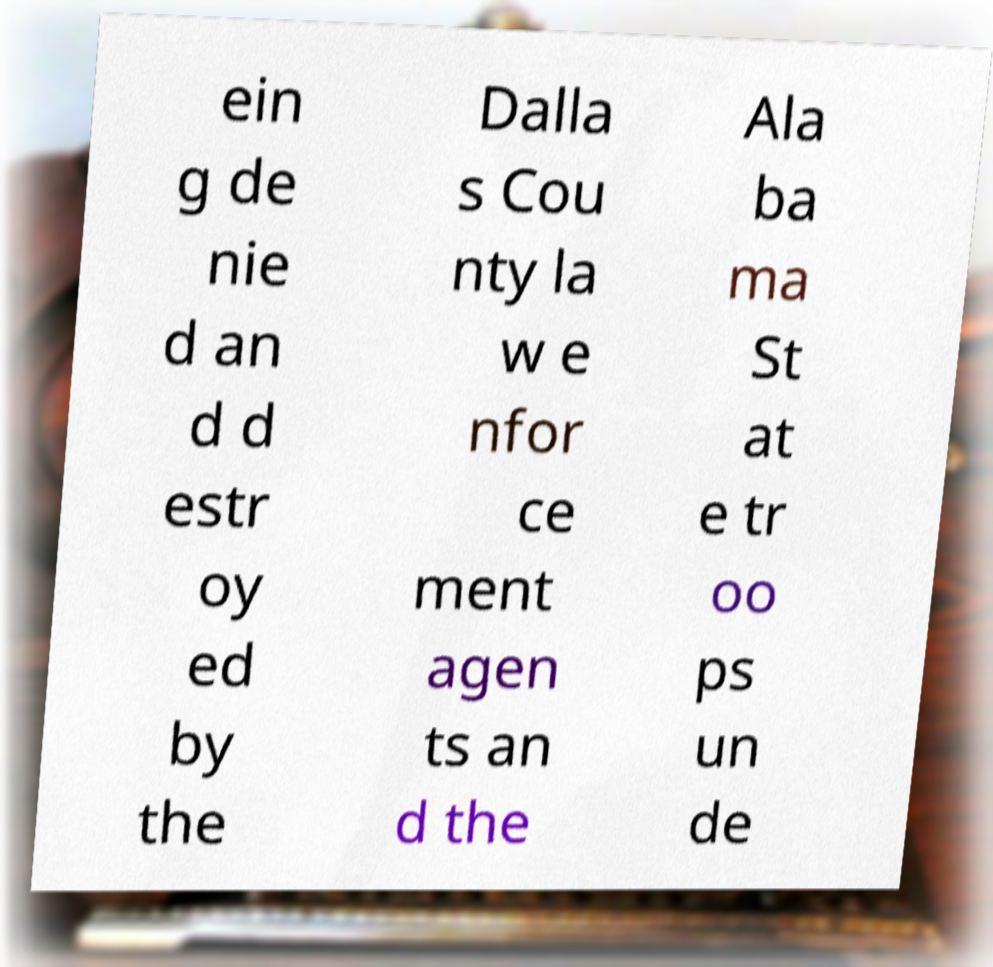What messages or text are displayed in this image? I need them in a readable, typed format. ein g de nie d an d d estr oy ed by the Dalla s Cou nty la w e nfor ce ment agen ts an d the Ala ba ma St at e tr oo ps un de 